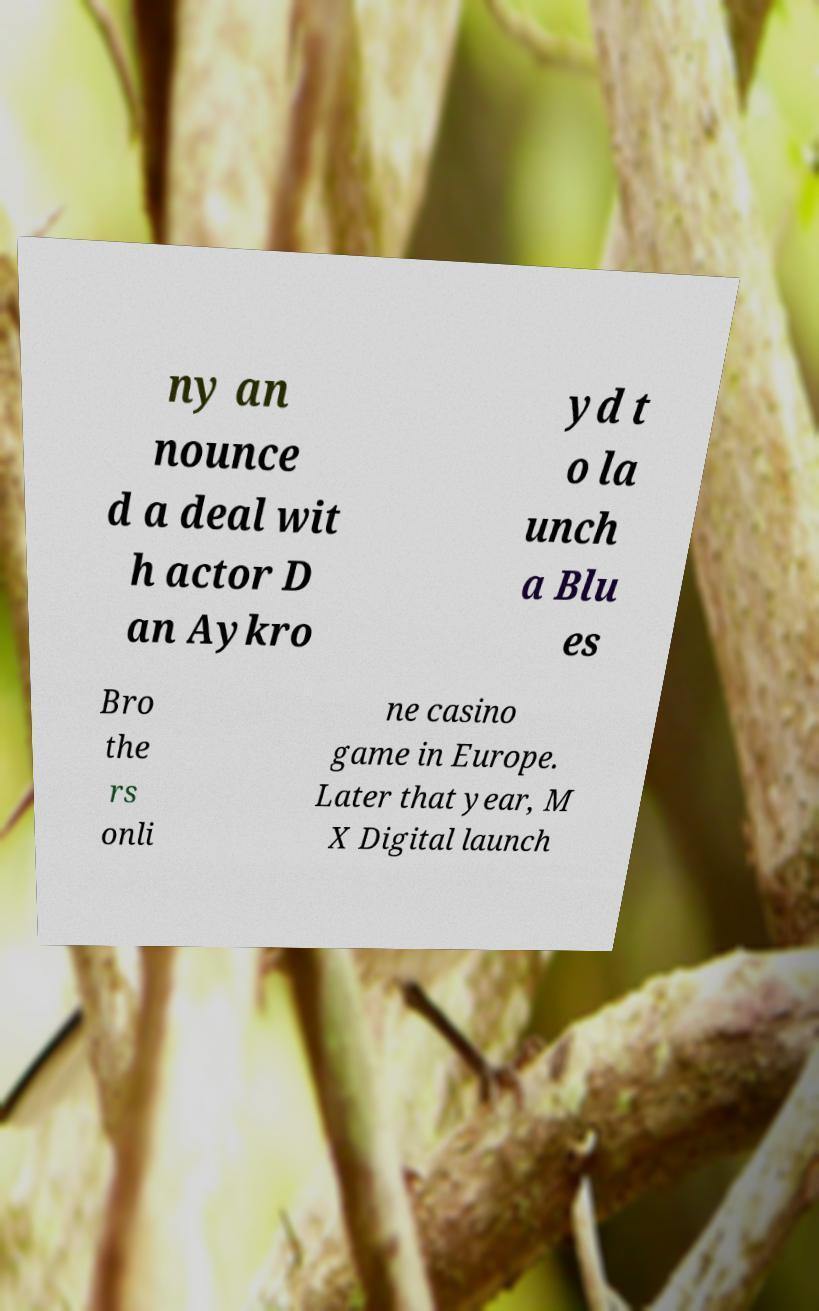What messages or text are displayed in this image? I need them in a readable, typed format. ny an nounce d a deal wit h actor D an Aykro yd t o la unch a Blu es Bro the rs onli ne casino game in Europe. Later that year, M X Digital launch 